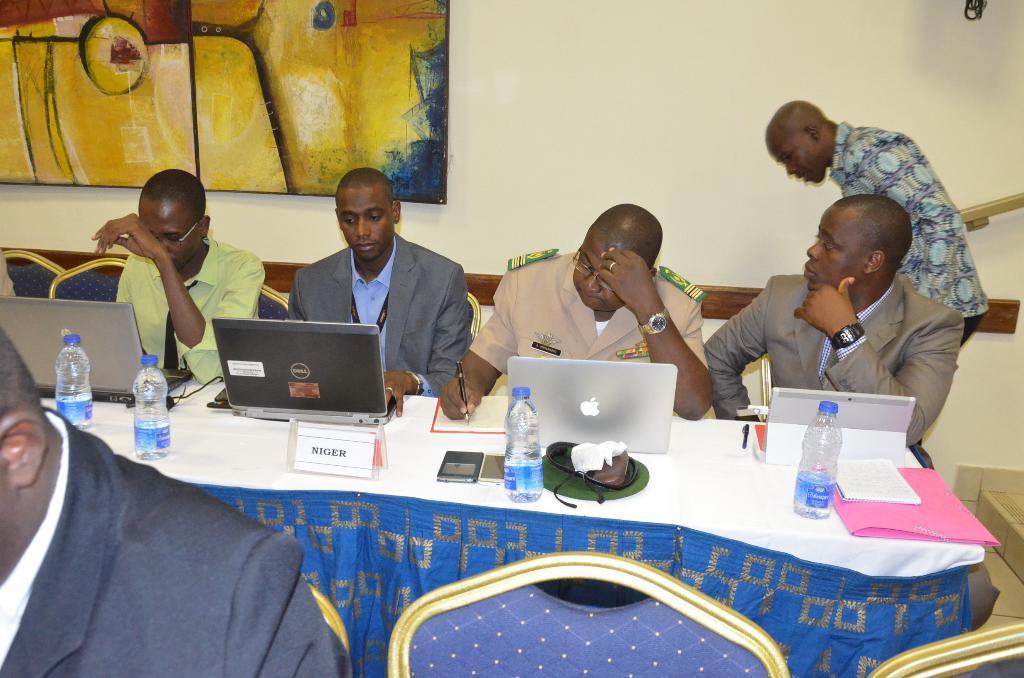Could you give a brief overview of what you see in this image? In this picture I can see few people are sitting in the chairs and a man standing and I can see few laptops, water bottles and a man writing with the help of a pen in the book and I can see painting on the wall. 